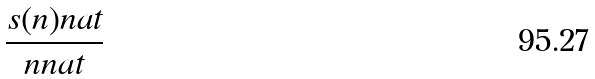<formula> <loc_0><loc_0><loc_500><loc_500>\frac { s ( n ) n a t } { n n a t }</formula> 